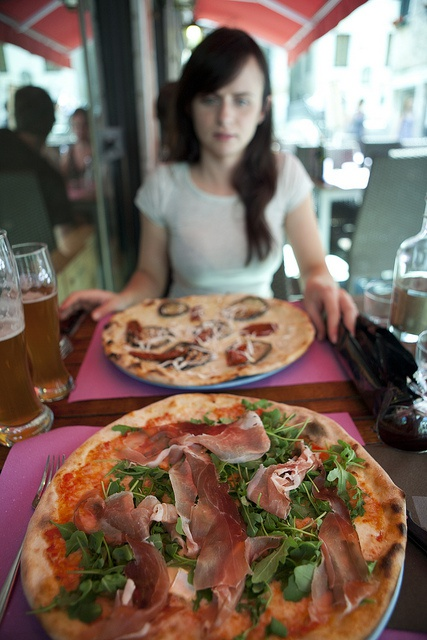Describe the objects in this image and their specific colors. I can see pizza in black, maroon, brown, and olive tones, people in black, darkgray, gray, and lightgray tones, pizza in black, tan, and gray tones, people in black, maroon, and gray tones, and cup in black, maroon, gray, and darkgray tones in this image. 